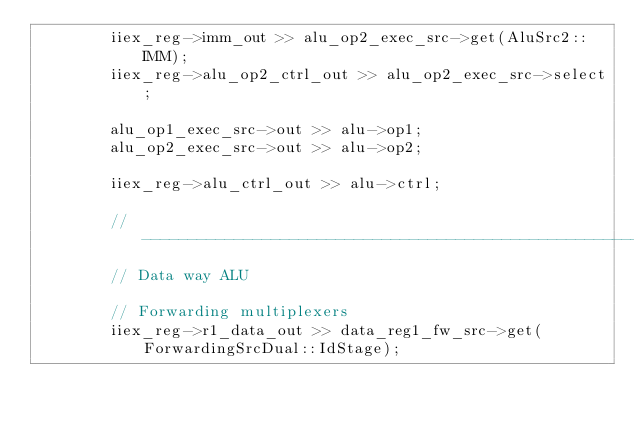Convert code to text. <code><loc_0><loc_0><loc_500><loc_500><_C_>        iiex_reg->imm_out >> alu_op2_exec_src->get(AluSrc2::IMM);
        iiex_reg->alu_op2_ctrl_out >> alu_op2_exec_src->select;

        alu_op1_exec_src->out >> alu->op1;
        alu_op2_exec_src->out >> alu->op2;

        iiex_reg->alu_ctrl_out >> alu->ctrl;

        // -----------------------------------------------------------------------
        // Data way ALU

        // Forwarding multiplexers
        iiex_reg->r1_data_out >> data_reg1_fw_src->get(ForwardingSrcDual::IdStage);</code> 